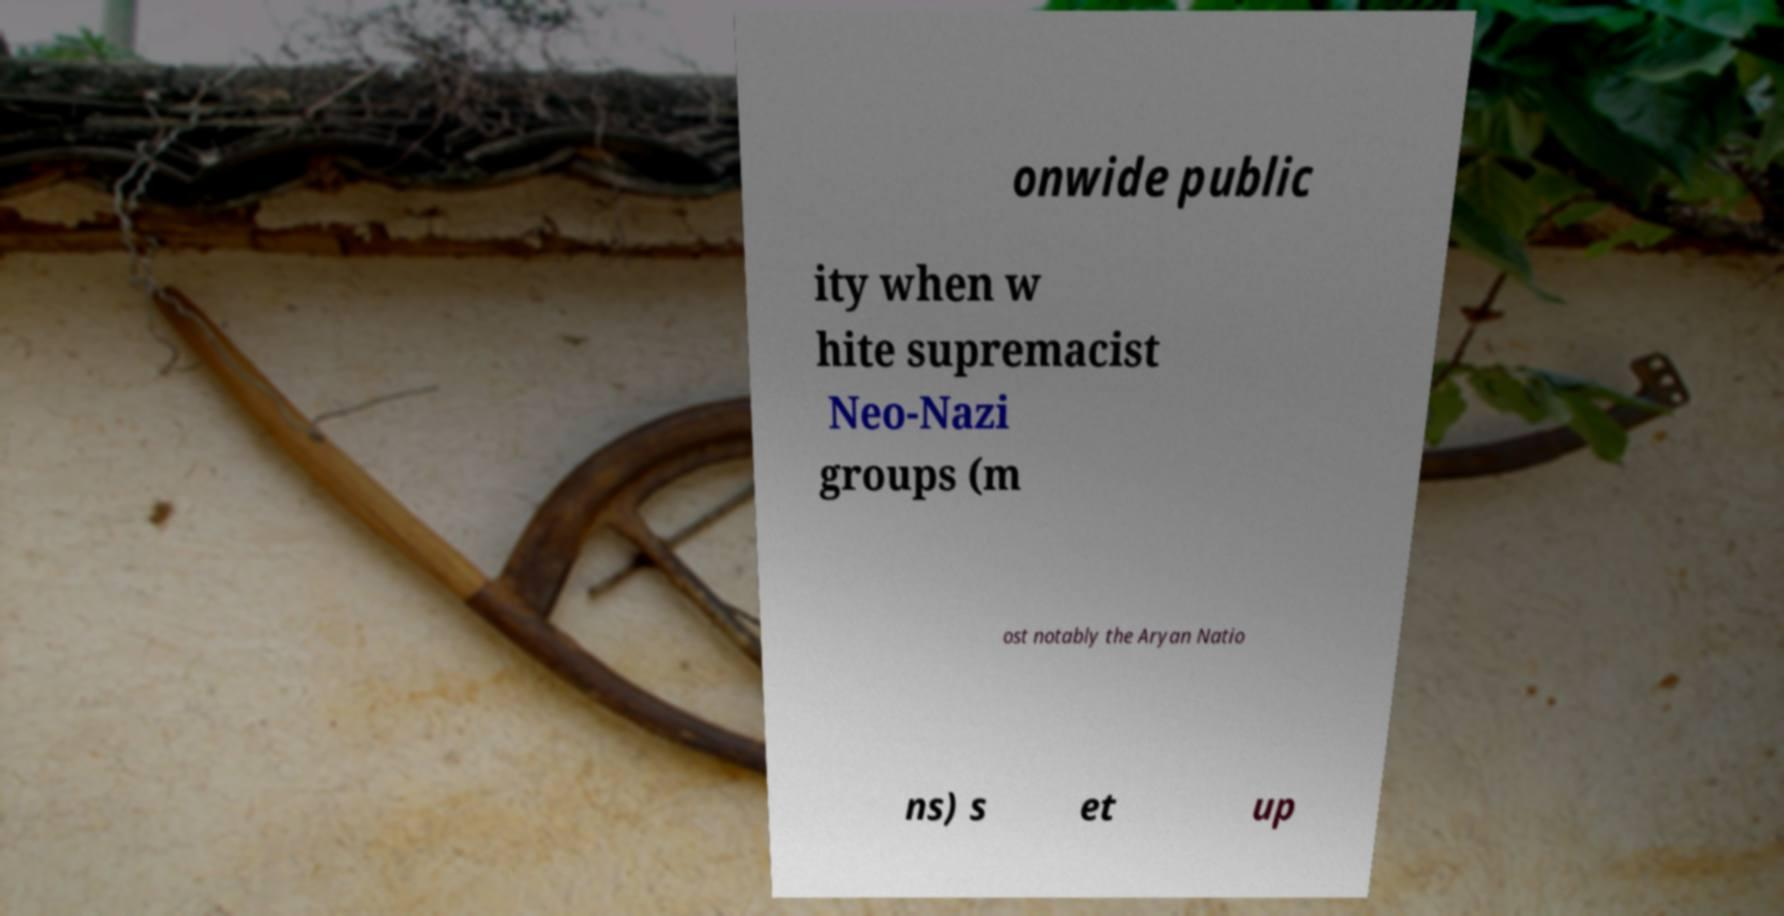Could you assist in decoding the text presented in this image and type it out clearly? onwide public ity when w hite supremacist Neo-Nazi groups (m ost notably the Aryan Natio ns) s et up 